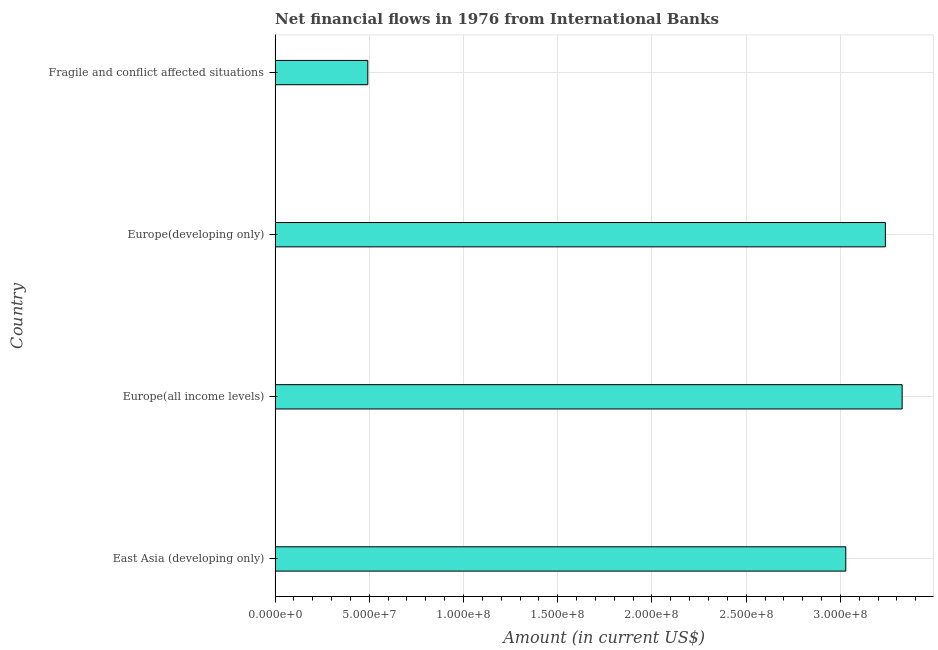Does the graph contain any zero values?
Keep it short and to the point. No. Does the graph contain grids?
Make the answer very short. Yes. What is the title of the graph?
Your answer should be compact. Net financial flows in 1976 from International Banks. What is the net financial flows from ibrd in Fragile and conflict affected situations?
Keep it short and to the point. 4.92e+07. Across all countries, what is the maximum net financial flows from ibrd?
Your answer should be compact. 3.33e+08. Across all countries, what is the minimum net financial flows from ibrd?
Keep it short and to the point. 4.92e+07. In which country was the net financial flows from ibrd maximum?
Give a very brief answer. Europe(all income levels). In which country was the net financial flows from ibrd minimum?
Your answer should be compact. Fragile and conflict affected situations. What is the sum of the net financial flows from ibrd?
Ensure brevity in your answer.  1.01e+09. What is the difference between the net financial flows from ibrd in East Asia (developing only) and Fragile and conflict affected situations?
Offer a very short reply. 2.54e+08. What is the average net financial flows from ibrd per country?
Give a very brief answer. 2.52e+08. What is the median net financial flows from ibrd?
Your answer should be compact. 3.13e+08. What is the ratio of the net financial flows from ibrd in Europe(developing only) to that in Fragile and conflict affected situations?
Make the answer very short. 6.58. What is the difference between the highest and the second highest net financial flows from ibrd?
Make the answer very short. 8.90e+06. What is the difference between the highest and the lowest net financial flows from ibrd?
Your response must be concise. 2.84e+08. Are all the bars in the graph horizontal?
Offer a terse response. Yes. How many countries are there in the graph?
Give a very brief answer. 4. What is the difference between two consecutive major ticks on the X-axis?
Offer a very short reply. 5.00e+07. Are the values on the major ticks of X-axis written in scientific E-notation?
Give a very brief answer. Yes. What is the Amount (in current US$) in East Asia (developing only)?
Give a very brief answer. 3.03e+08. What is the Amount (in current US$) of Europe(all income levels)?
Your response must be concise. 3.33e+08. What is the Amount (in current US$) of Europe(developing only)?
Your response must be concise. 3.24e+08. What is the Amount (in current US$) in Fragile and conflict affected situations?
Your answer should be compact. 4.92e+07. What is the difference between the Amount (in current US$) in East Asia (developing only) and Europe(all income levels)?
Offer a terse response. -2.99e+07. What is the difference between the Amount (in current US$) in East Asia (developing only) and Europe(developing only)?
Your response must be concise. -2.10e+07. What is the difference between the Amount (in current US$) in East Asia (developing only) and Fragile and conflict affected situations?
Give a very brief answer. 2.54e+08. What is the difference between the Amount (in current US$) in Europe(all income levels) and Europe(developing only)?
Provide a succinct answer. 8.90e+06. What is the difference between the Amount (in current US$) in Europe(all income levels) and Fragile and conflict affected situations?
Keep it short and to the point. 2.84e+08. What is the difference between the Amount (in current US$) in Europe(developing only) and Fragile and conflict affected situations?
Provide a short and direct response. 2.75e+08. What is the ratio of the Amount (in current US$) in East Asia (developing only) to that in Europe(all income levels)?
Your answer should be compact. 0.91. What is the ratio of the Amount (in current US$) in East Asia (developing only) to that in Europe(developing only)?
Keep it short and to the point. 0.94. What is the ratio of the Amount (in current US$) in East Asia (developing only) to that in Fragile and conflict affected situations?
Offer a terse response. 6.15. What is the ratio of the Amount (in current US$) in Europe(all income levels) to that in Europe(developing only)?
Give a very brief answer. 1.03. What is the ratio of the Amount (in current US$) in Europe(all income levels) to that in Fragile and conflict affected situations?
Offer a terse response. 6.76. What is the ratio of the Amount (in current US$) in Europe(developing only) to that in Fragile and conflict affected situations?
Provide a succinct answer. 6.58. 